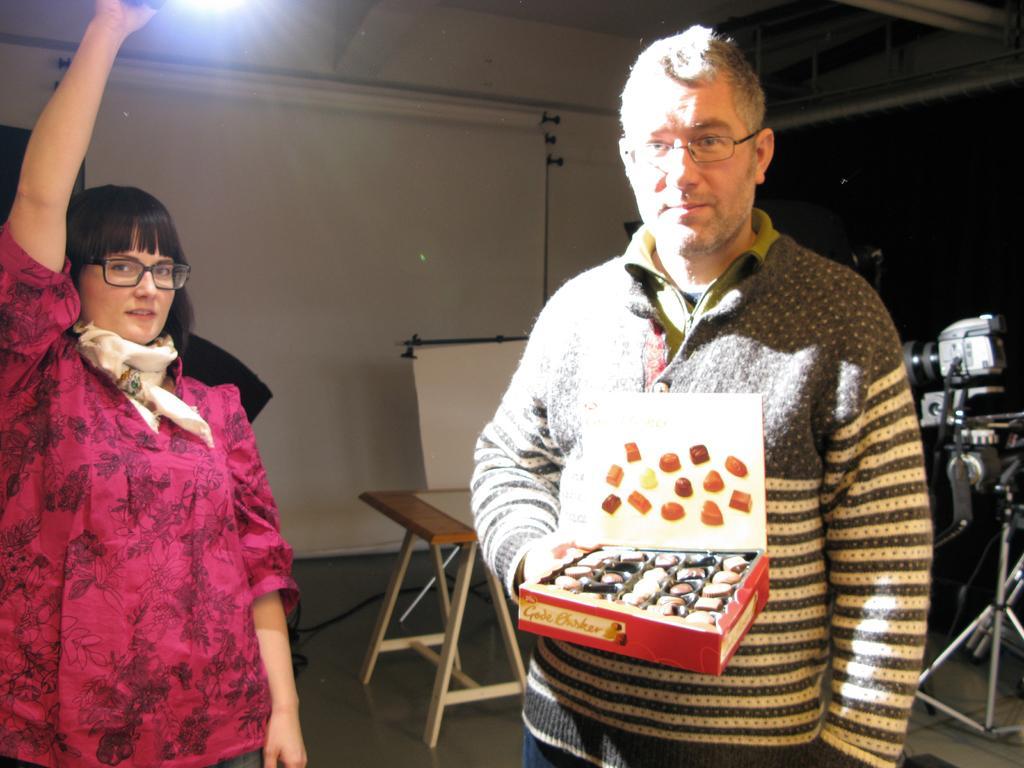Can you describe this image briefly? In this image there is a man on the right side who is holding the chocolate box. Beside him there is a woman who is holding the torch light by raising her hand. In the background there is a table. Behind the table there is a screen. On the right side there is a camera. 